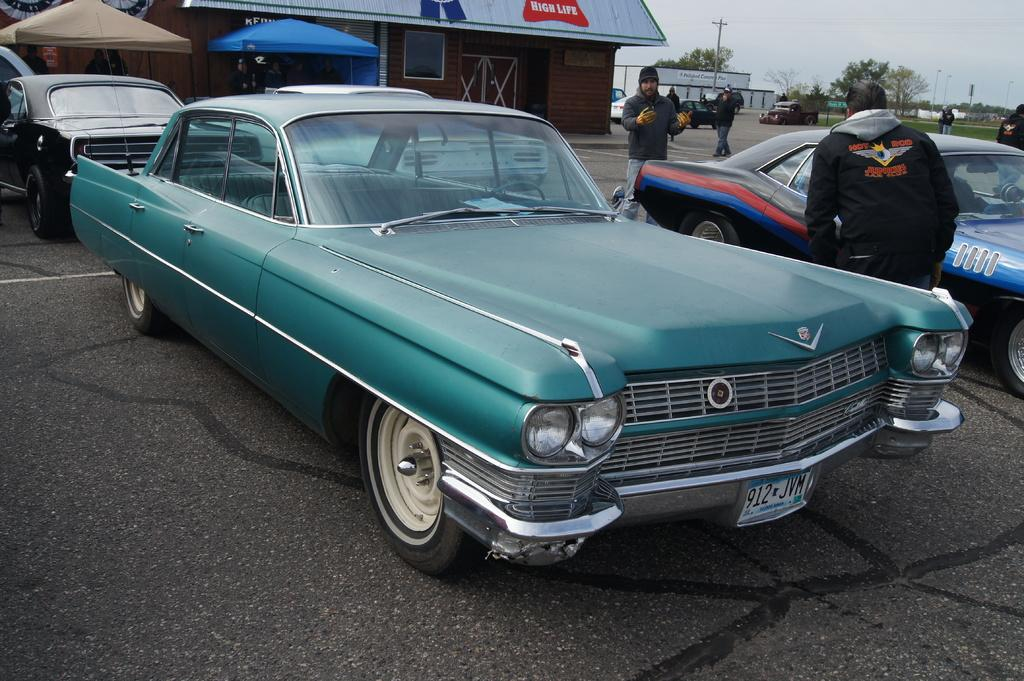What types of objects can be seen in the image? There are vehicles in the image. Where are the vehicles located in relation to other structures? The vehicles are in front of buildings. Can you identify any living beings in the image? Yes, there are people visible in the image. What type of natural elements can be seen in the image? There are trees in the image. Is there a wilderness area visible in the image? No, there is no wilderness area visible in the image; it features vehicles, buildings, people, and trees in an urban or suburban setting. Can you hear an argument taking place in the image? There is no audio component to the image, so it is not possible to determine if an argument is taking place. 